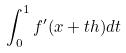Convert formula to latex. <formula><loc_0><loc_0><loc_500><loc_500>\int _ { 0 } ^ { 1 } f ^ { \prime } ( x + t h ) d t</formula> 